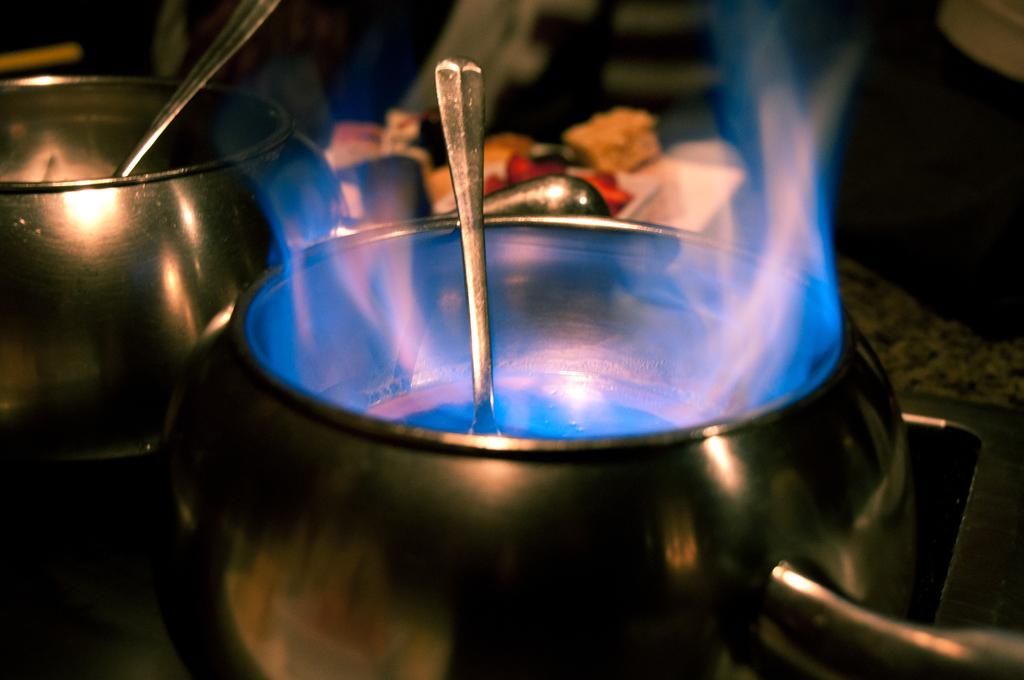How many dishes can be seen in the image? There are two dishes in the image. What is happening in one of the dishes? There is fire in one of the dishes. What utensils are present in the dishes? Spoons are present in the dishes. What type of observation can be made about the pain experienced by the dishes in the image? There is no indication of pain being experienced by the dishes in the image. 